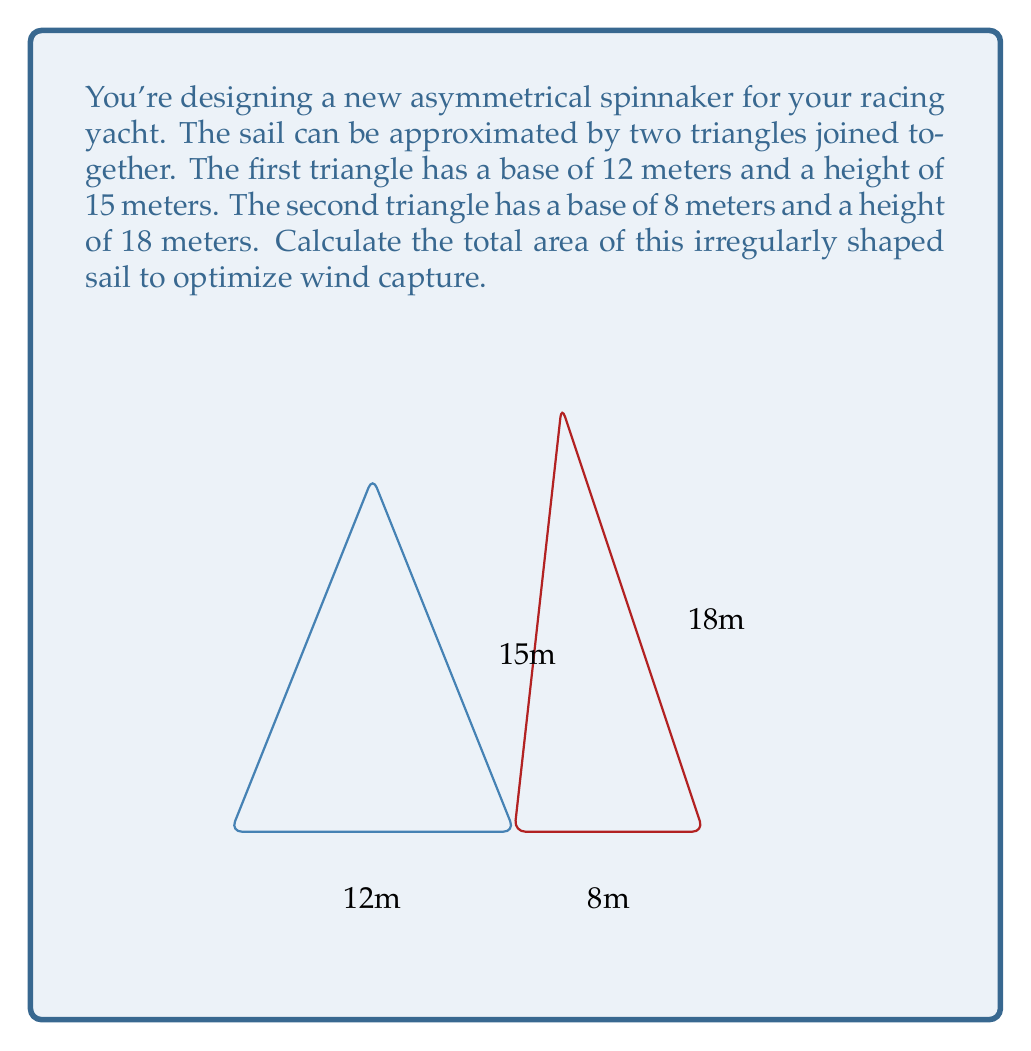Teach me how to tackle this problem. To calculate the total area of the irregularly shaped sail, we need to find the areas of both triangles and sum them up.

1. Area of the first triangle:
   $$A_1 = \frac{1}{2} \times base \times height$$
   $$A_1 = \frac{1}{2} \times 12 \times 15 = 90 \text{ m}^2$$

2. Area of the second triangle:
   $$A_2 = \frac{1}{2} \times base \times height$$
   $$A_2 = \frac{1}{2} \times 8 \times 18 = 72 \text{ m}^2$$

3. Total area of the sail:
   $$A_{total} = A_1 + A_2 = 90 + 72 = 162 \text{ m}^2$$

Therefore, the total area of the irregularly shaped sail is 162 square meters.
Answer: 162 m² 